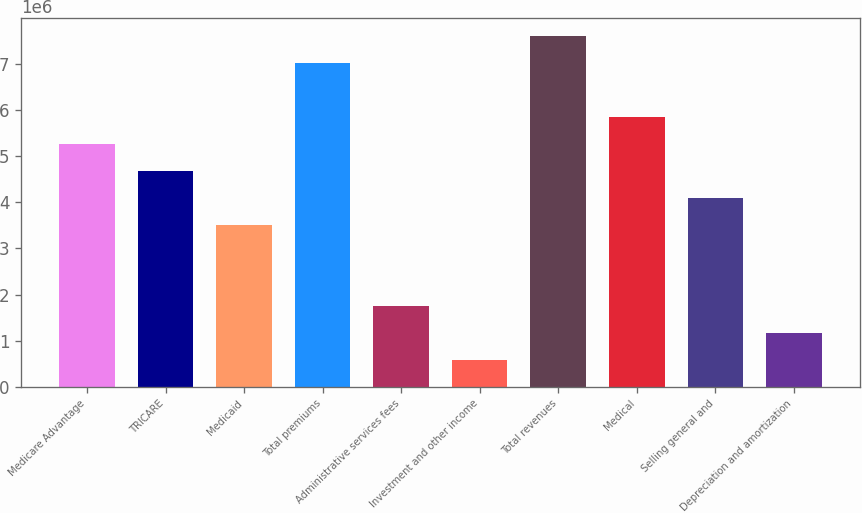<chart> <loc_0><loc_0><loc_500><loc_500><bar_chart><fcel>Medicare Advantage<fcel>TRICARE<fcel>Medicaid<fcel>Total premiums<fcel>Administrative services fees<fcel>Investment and other income<fcel>Total revenues<fcel>Medical<fcel>Selling general and<fcel>Depreciation and amortization<nl><fcel>5.27302e+06<fcel>4.68763e+06<fcel>3.51685e+06<fcel>7.02919e+06<fcel>1.76067e+06<fcel>589888<fcel>7.61459e+06<fcel>5.85841e+06<fcel>4.10224e+06<fcel>1.17528e+06<nl></chart> 